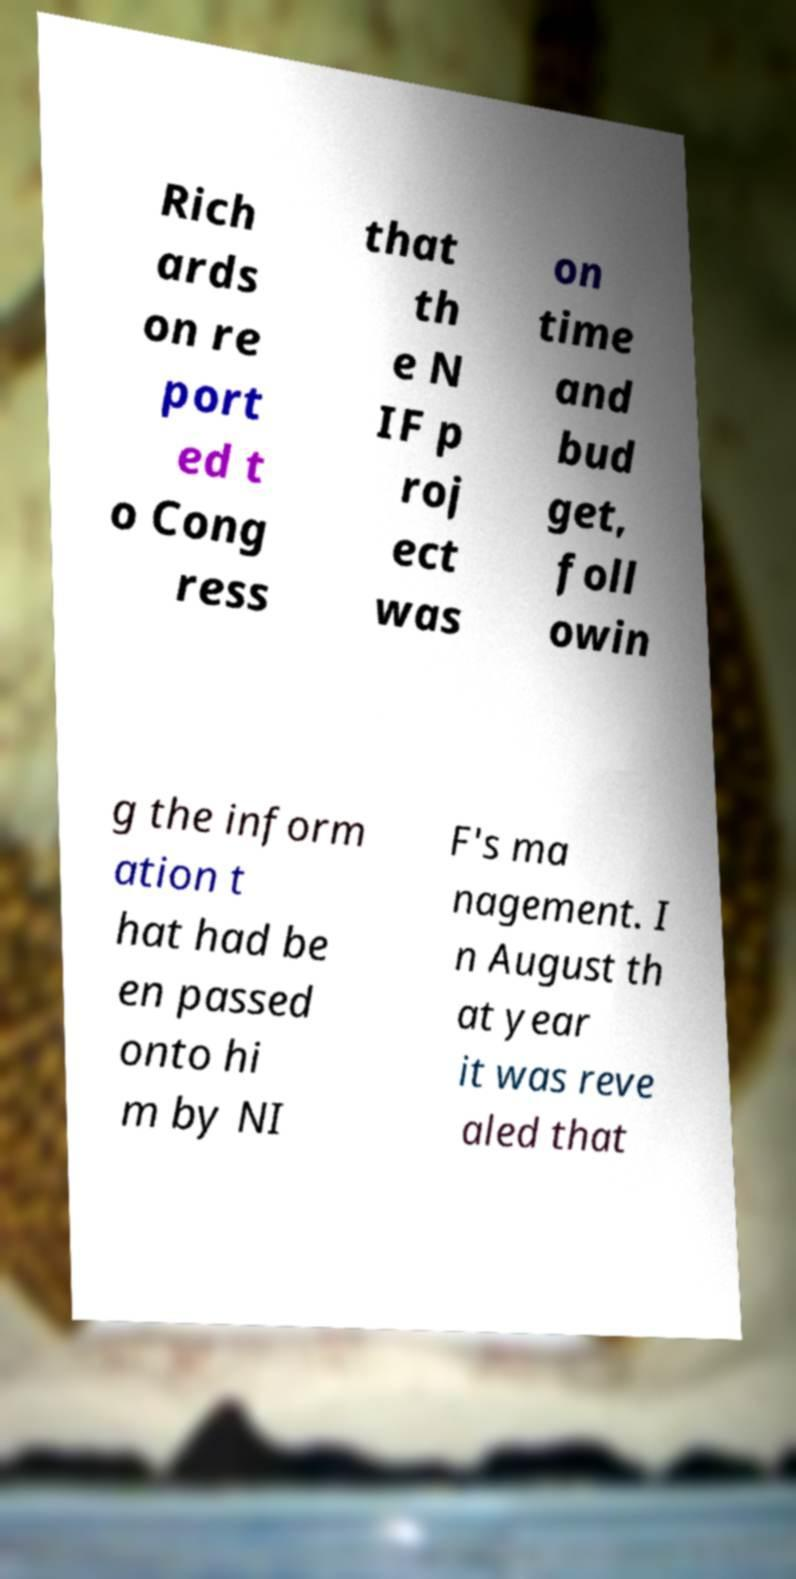For documentation purposes, I need the text within this image transcribed. Could you provide that? Rich ards on re port ed t o Cong ress that th e N IF p roj ect was on time and bud get, foll owin g the inform ation t hat had be en passed onto hi m by NI F's ma nagement. I n August th at year it was reve aled that 